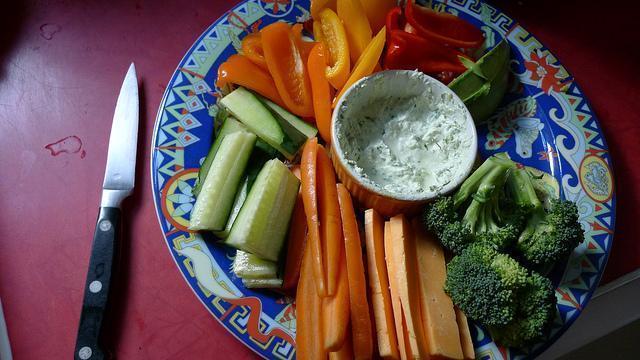What is the white substance in the middle of the plate used for?
From the following four choices, select the correct answer to address the question.
Options: Rubbing, dipping, pasting, drinking. Dipping. 